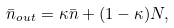Convert formula to latex. <formula><loc_0><loc_0><loc_500><loc_500>\bar { n } _ { o u t } = \kappa \bar { n } + ( 1 - \kappa ) N ,</formula> 